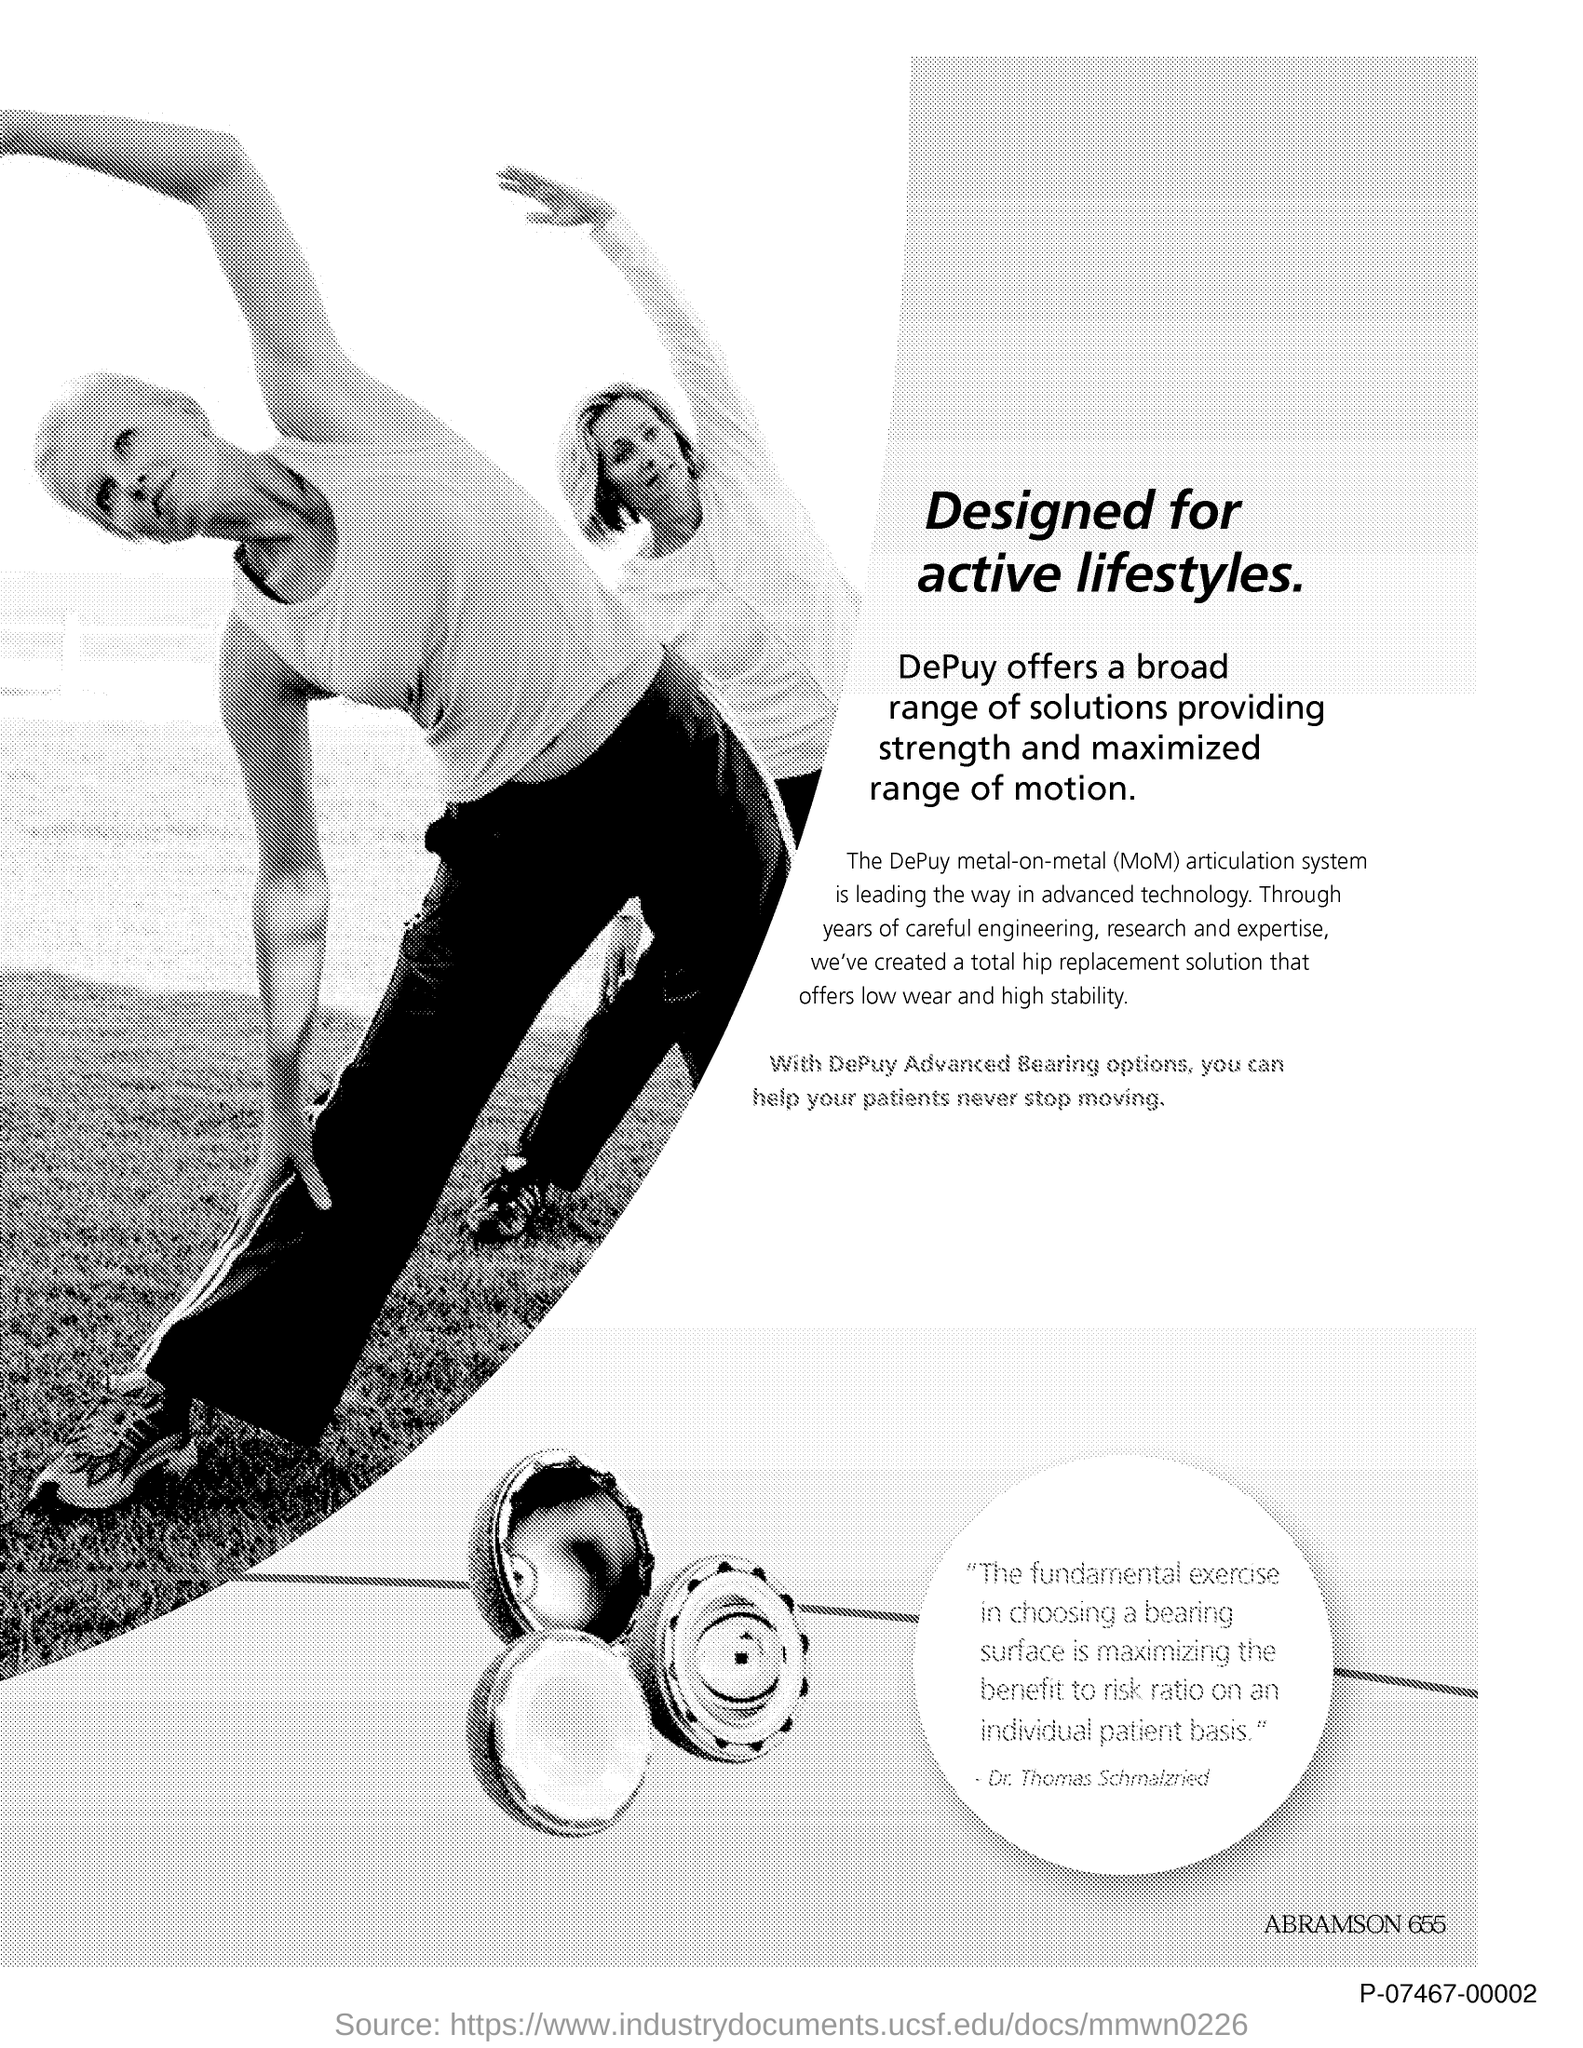What is the title of the document?
Ensure brevity in your answer.  Designed for active lifestyles. 